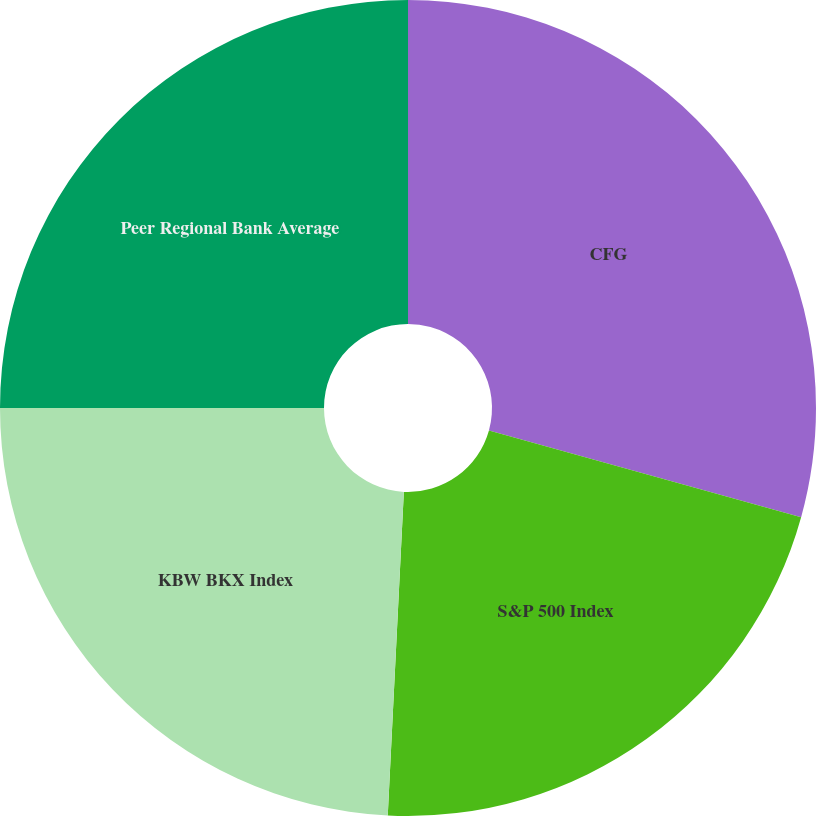Convert chart to OTSL. <chart><loc_0><loc_0><loc_500><loc_500><pie_chart><fcel>CFG<fcel>S&P 500 Index<fcel>KBW BKX Index<fcel>Peer Regional Bank Average<nl><fcel>29.31%<fcel>21.48%<fcel>24.21%<fcel>25.0%<nl></chart> 